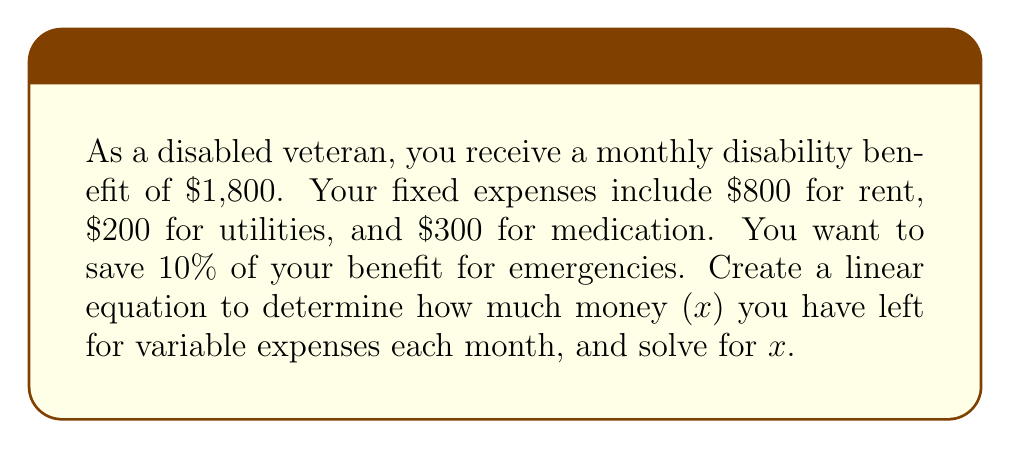Show me your answer to this math problem. Let's approach this step-by-step:

1) First, let's identify the components of our equation:
   - Monthly benefit: $1,800
   - Fixed expenses: $800 + $200 + $300 = $1,300
   - Savings: 10% of $1,800 = $180
   - Variable expenses: $x$

2) Now, we can set up our linear equation:
   $$1800 = 1300 + 180 + x$$

3) The left side represents the total benefit, and the right side represents all the allocations of this benefit.

4) To solve for $x$, we need to isolate it:
   $$1800 - 1300 - 180 = x$$

5) Simplify:
   $$320 = x$$

Therefore, you have $320 left for variable expenses each month.
Answer: $320 